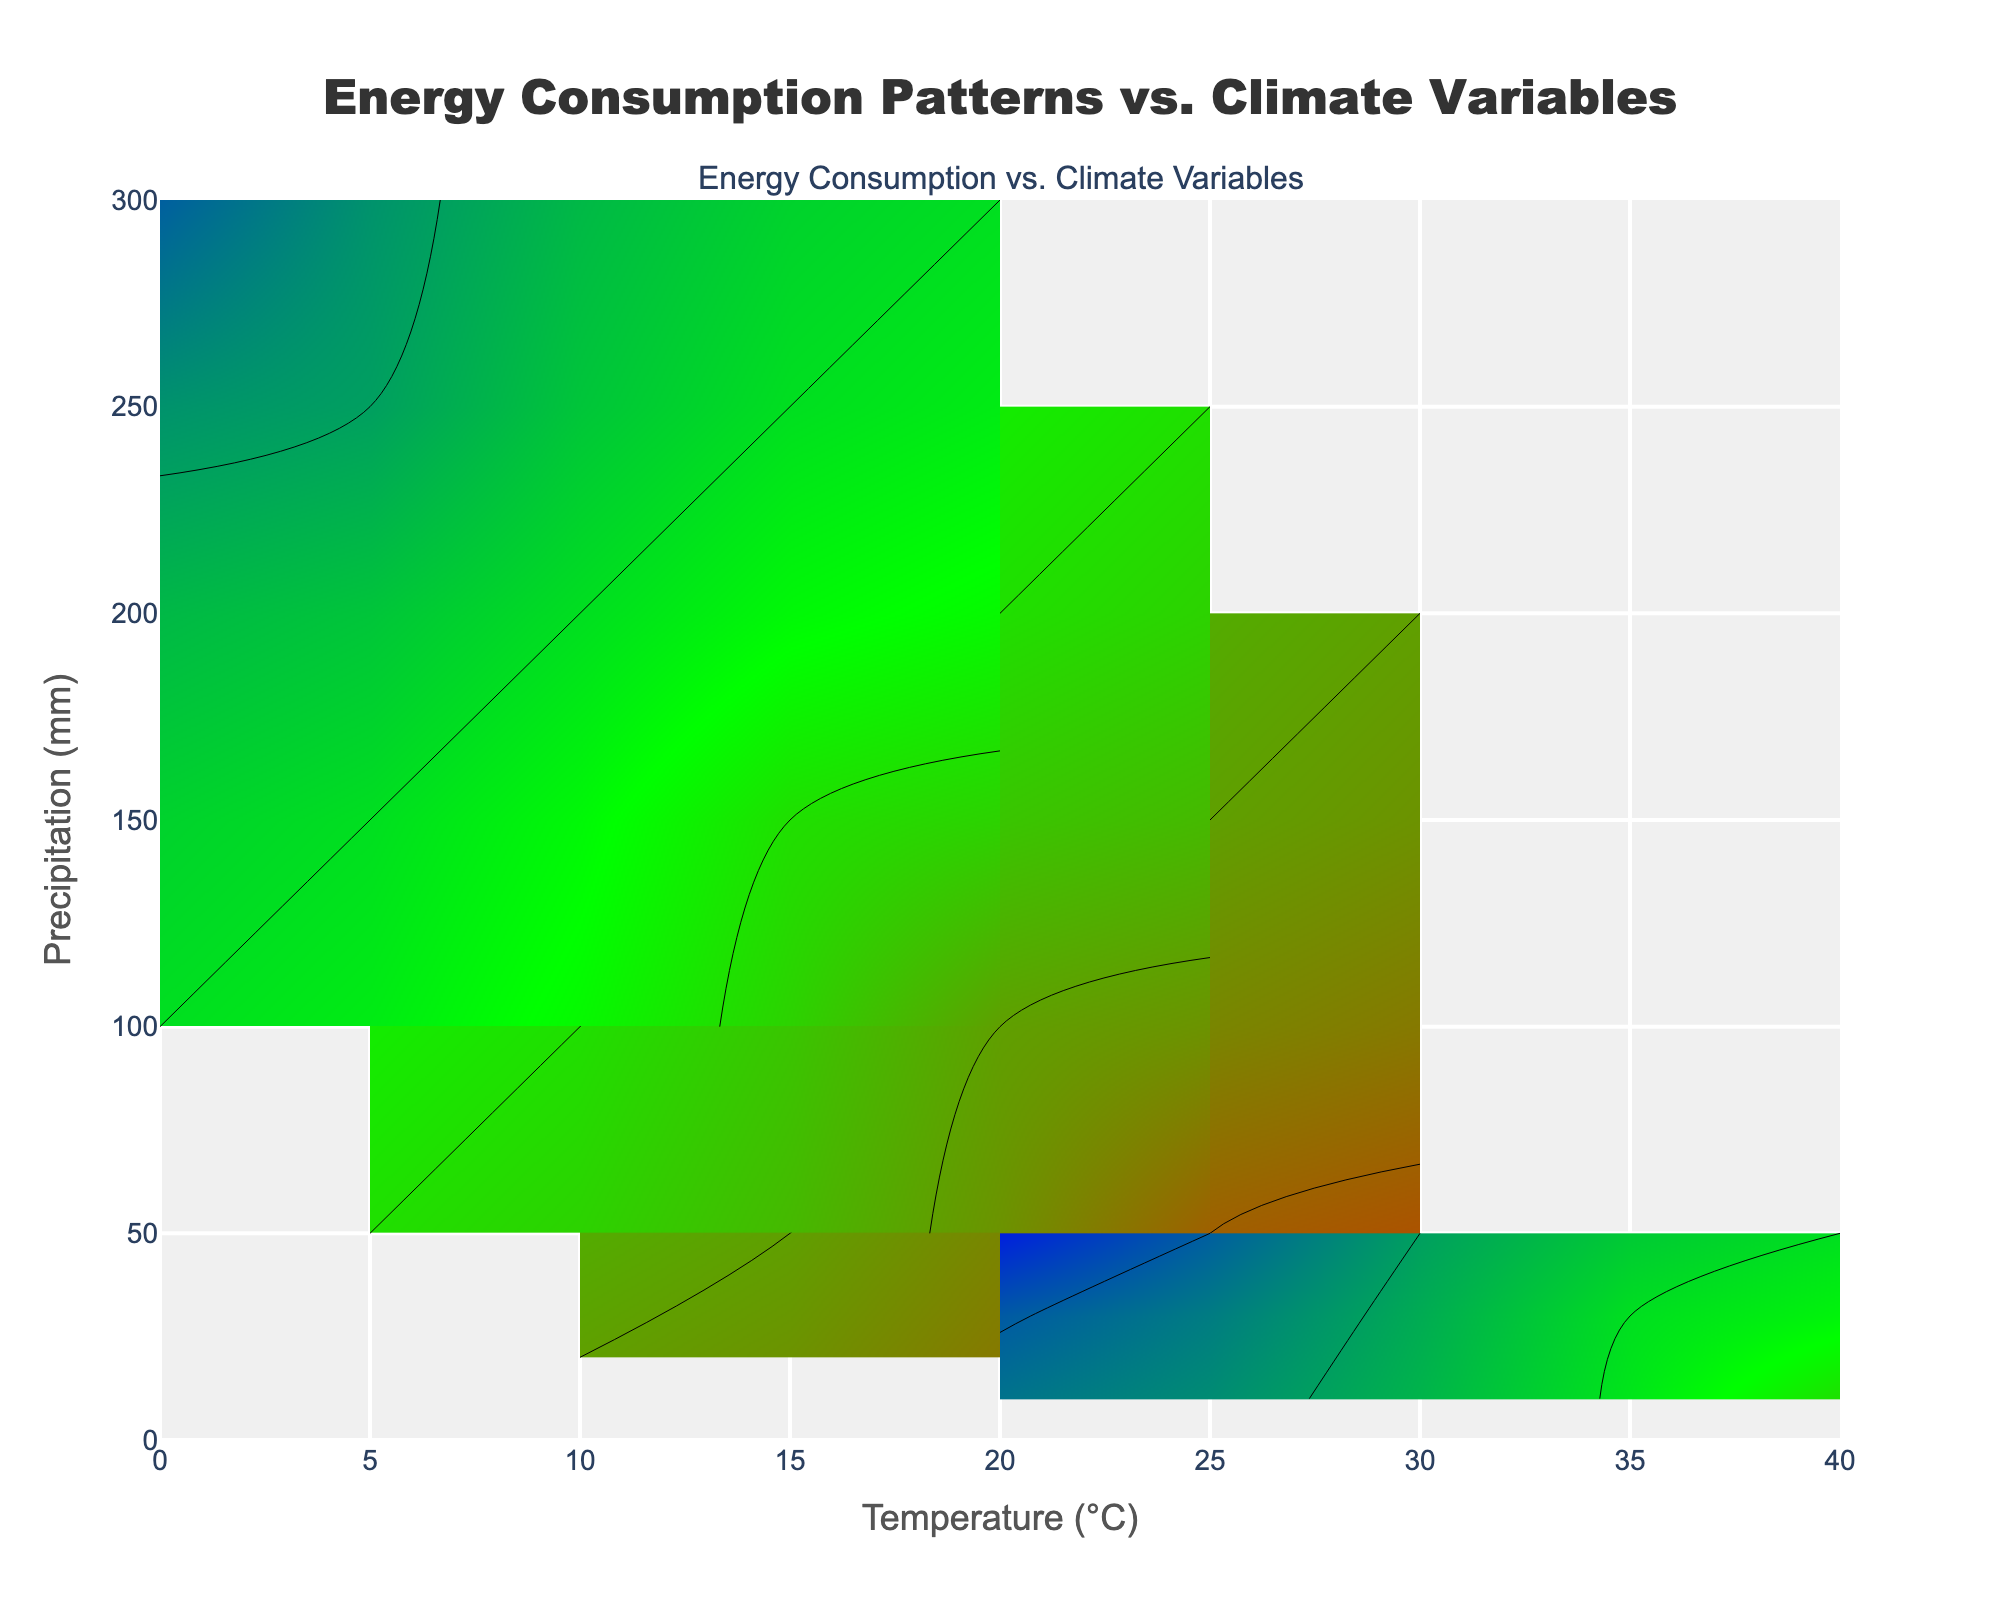What is the title of the figure? The title is usually displayed prominently at the top of the figure. Here, we can find it reading "Energy Consumption Patterns vs. Climate Variables" near the top center.
Answer: Energy Consumption Patterns vs. Climate Variables Which axis represents Temperature? The axis labels help us identify which variable is represented on each axis. The x-axis is labeled "Temperature (°C)," so the x-axis represents Temperature.
Answer: x-axis What is the range of the Precipitation axis? The y-axis has tick marks indicating its range. By examining these marks, we can see that the Precipitation axis (y-axis) ranges from 0 to 300 mm.
Answer: 0 to 300 mm Which region shows energy consumption of 1600 units at the highest Temperature? To answer this question, identify the contour lines for 1600 units of energy consumption and observe the highest Temperature values they intersect. Europe records 1600 units at the highest Temperature of 25°C.
Answer: Europe At 20°C, which region has the highest Precipitation value? Locate the x-axis at 20°C and then trace vertically upwards along the contour lines. Asia records the highest Precipitation value, which is at 100 mm.
Answer: Asia How does energy consumption change with increasing Temperature in North America? Examine the contour lines specific to North America as the temperature increases. The contour lines indicate that as Temperature increases, energy consumption also increases from 1500 to 1900 units.
Answer: Increases Compare the energy consumption at 15°C and 25°C in Europe. Find the 15°C and 25°C points along the x-axis, and then look for their corresponding energy consumption values. At 15°C, Europe consumes 1600 units, and at 25°C, it consumes 1800 units.
Answer: 1600 units at 15°C, 1800 units at 25°C Which region has the lowest energy consumption and at what climate conditions? By examining the contour lines and corresponding labels, we find that Australia has the lowest energy consumption at 20°C and 50 mm Precipitation.
Answer: Australia at 20°C and 50 mm What is the trend of energy consumption as Precipitation decreases in Asia? By observing the contour lines in Asia as Precipitation decreases, it is evident that energy consumption increases from 1300 to 1700 units.
Answer: Increases 